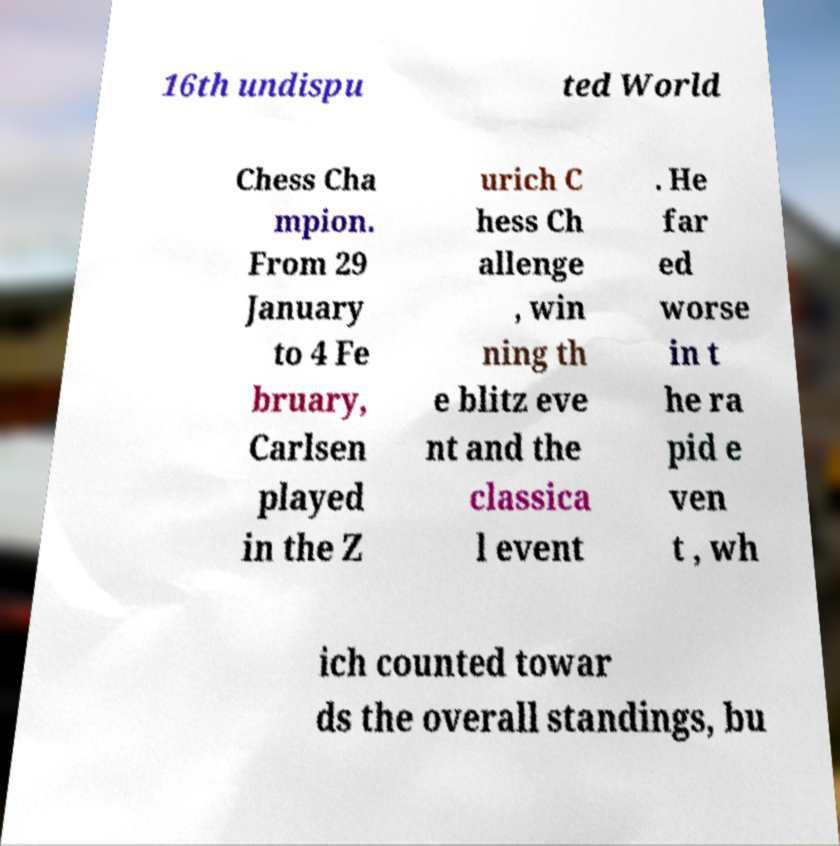Please identify and transcribe the text found in this image. 16th undispu ted World Chess Cha mpion. From 29 January to 4 Fe bruary, Carlsen played in the Z urich C hess Ch allenge , win ning th e blitz eve nt and the classica l event . He far ed worse in t he ra pid e ven t , wh ich counted towar ds the overall standings, bu 